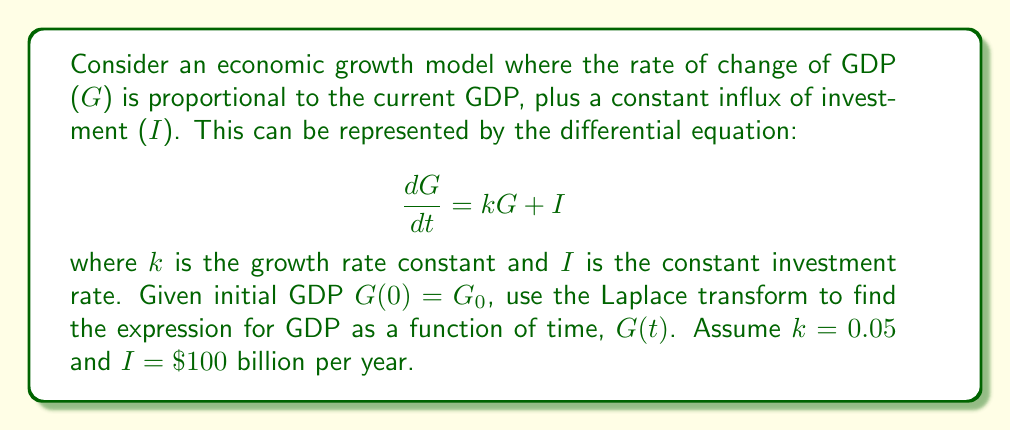Could you help me with this problem? Let's solve this step-by-step using the Laplace transform:

1) First, take the Laplace transform of both sides of the equation:

   $$\mathcal{L}\left\{\frac{dG}{dt}\right\} = \mathcal{L}\{kG + I\}$$

2) Using the Laplace transform properties:

   $$s\mathcal{L}\{G\} - G_0 = k\mathcal{L}\{G\} + \frac{I}{s}$$

3) Let $\mathcal{L}\{G\} = \bar{G}(s)$. Then:

   $$s\bar{G}(s) - G_0 = k\bar{G}(s) + \frac{I}{s}$$

4) Rearrange the equation:

   $$s\bar{G}(s) - k\bar{G}(s) = G_0 + \frac{I}{s}$$
   $$(s-k)\bar{G}(s) = G_0 + \frac{I}{s}$$

5) Solve for $\bar{G}(s)$:

   $$\bar{G}(s) = \frac{G_0}{s-k} + \frac{I}{s(s-k)}$$

6) This can be rewritten as:

   $$\bar{G}(s) = \frac{G_0}{s-k} + \frac{I}{k}\left(\frac{1}{s} - \frac{1}{s-k}\right)$$

7) Now, take the inverse Laplace transform:

   $$G(t) = G_0e^{kt} + \frac{I}{k}(1 - e^{kt})$$

8) Substitute the given values k = 0.05 and I = 100:

   $$G(t) = G_0e^{0.05t} + 2000(1 - e^{0.05t})$$

This is the final expression for GDP as a function of time.
Answer: $$G(t) = G_0e^{0.05t} + 2000(1 - e^{0.05t})$$ 